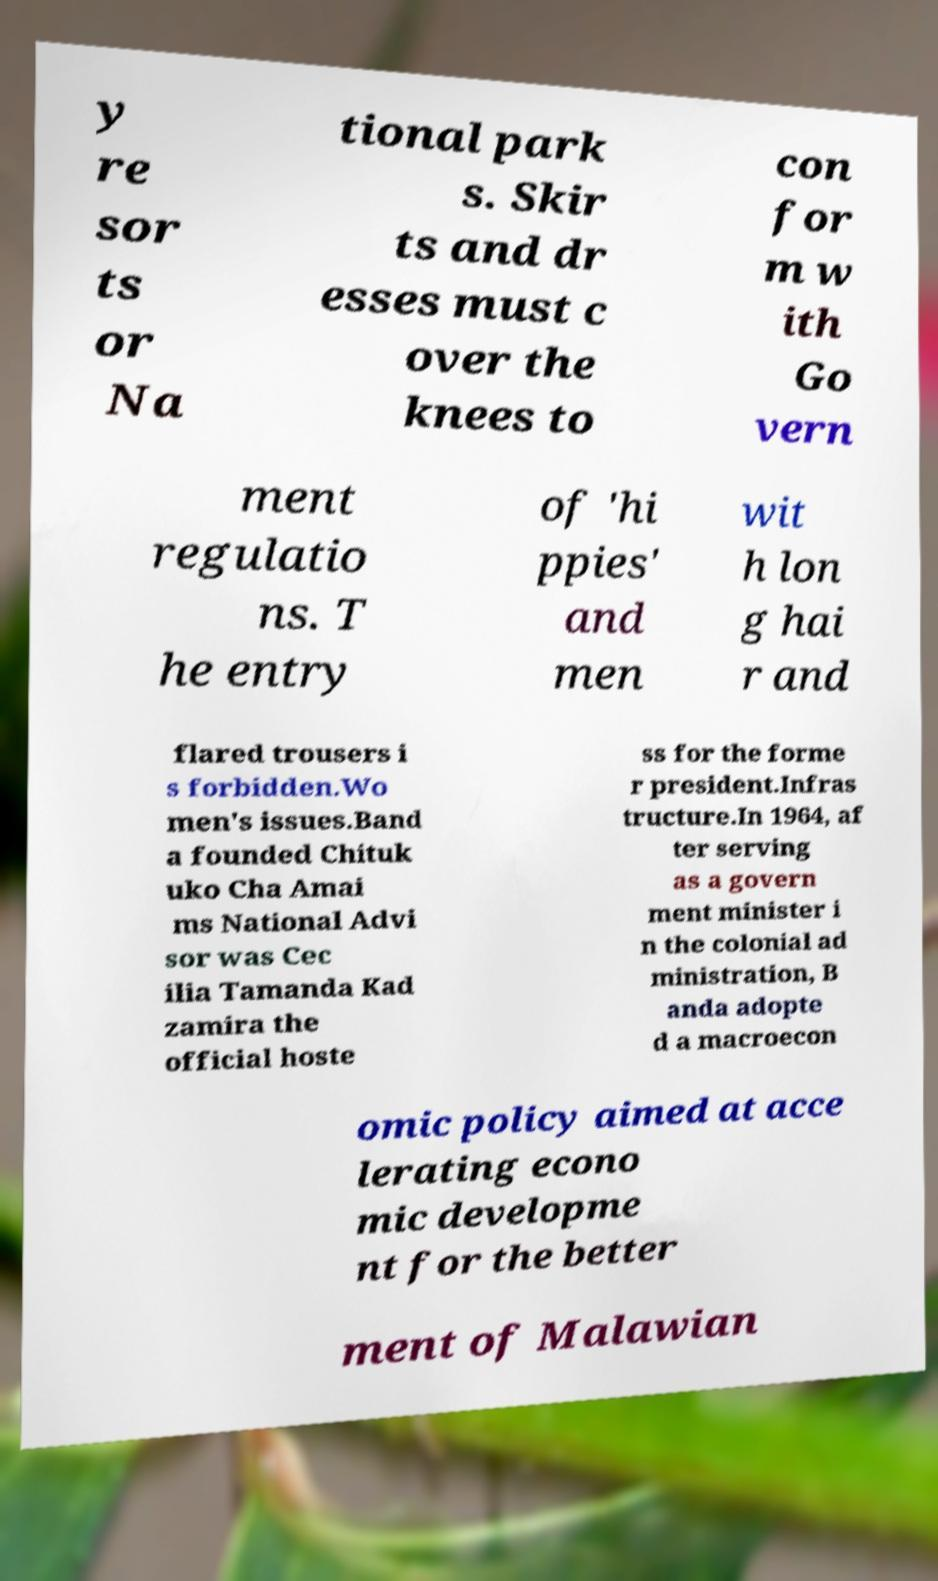What messages or text are displayed in this image? I need them in a readable, typed format. y re sor ts or Na tional park s. Skir ts and dr esses must c over the knees to con for m w ith Go vern ment regulatio ns. T he entry of 'hi ppies' and men wit h lon g hai r and flared trousers i s forbidden.Wo men's issues.Band a founded Chituk uko Cha Amai ms National Advi sor was Cec ilia Tamanda Kad zamira the official hoste ss for the forme r president.Infras tructure.In 1964, af ter serving as a govern ment minister i n the colonial ad ministration, B anda adopte d a macroecon omic policy aimed at acce lerating econo mic developme nt for the better ment of Malawian 